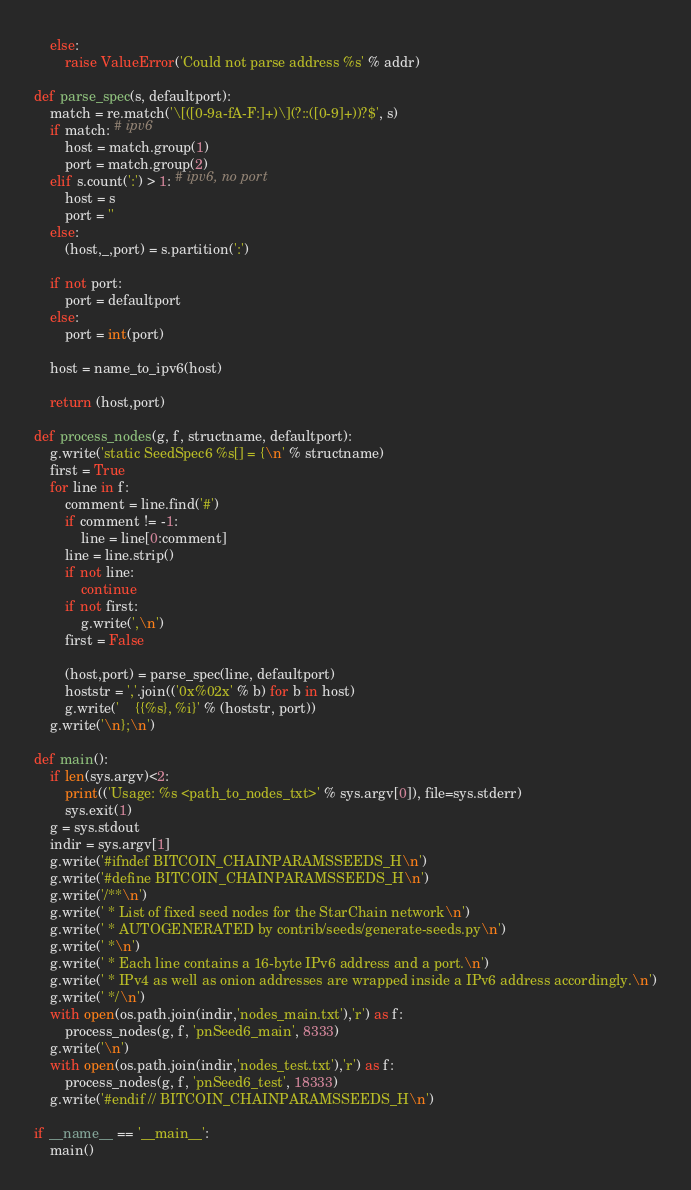Convert code to text. <code><loc_0><loc_0><loc_500><loc_500><_Python_>    else:
        raise ValueError('Could not parse address %s' % addr)

def parse_spec(s, defaultport):
    match = re.match('\[([0-9a-fA-F:]+)\](?::([0-9]+))?$', s)
    if match: # ipv6
        host = match.group(1)
        port = match.group(2)
    elif s.count(':') > 1: # ipv6, no port
        host = s
        port = ''
    else:
        (host,_,port) = s.partition(':')

    if not port:
        port = defaultport
    else:
        port = int(port)

    host = name_to_ipv6(host)

    return (host,port)

def process_nodes(g, f, structname, defaultport):
    g.write('static SeedSpec6 %s[] = {\n' % structname)
    first = True
    for line in f:
        comment = line.find('#')
        if comment != -1:
            line = line[0:comment]
        line = line.strip()
        if not line:
            continue
        if not first:
            g.write(',\n')
        first = False

        (host,port) = parse_spec(line, defaultport)
        hoststr = ','.join(('0x%02x' % b) for b in host)
        g.write('    {{%s}, %i}' % (hoststr, port))
    g.write('\n};\n')

def main():
    if len(sys.argv)<2:
        print(('Usage: %s <path_to_nodes_txt>' % sys.argv[0]), file=sys.stderr)
        sys.exit(1)
    g = sys.stdout
    indir = sys.argv[1]
    g.write('#ifndef BITCOIN_CHAINPARAMSSEEDS_H\n')
    g.write('#define BITCOIN_CHAINPARAMSSEEDS_H\n')
    g.write('/**\n')
    g.write(' * List of fixed seed nodes for the StarChain network\n')
    g.write(' * AUTOGENERATED by contrib/seeds/generate-seeds.py\n')
    g.write(' *\n')
    g.write(' * Each line contains a 16-byte IPv6 address and a port.\n')
    g.write(' * IPv4 as well as onion addresses are wrapped inside a IPv6 address accordingly.\n')
    g.write(' */\n')
    with open(os.path.join(indir,'nodes_main.txt'),'r') as f:
        process_nodes(g, f, 'pnSeed6_main', 8333)
    g.write('\n')
    with open(os.path.join(indir,'nodes_test.txt'),'r') as f:
        process_nodes(g, f, 'pnSeed6_test', 18333)
    g.write('#endif // BITCOIN_CHAINPARAMSSEEDS_H\n')
            
if __name__ == '__main__':
    main()

</code> 